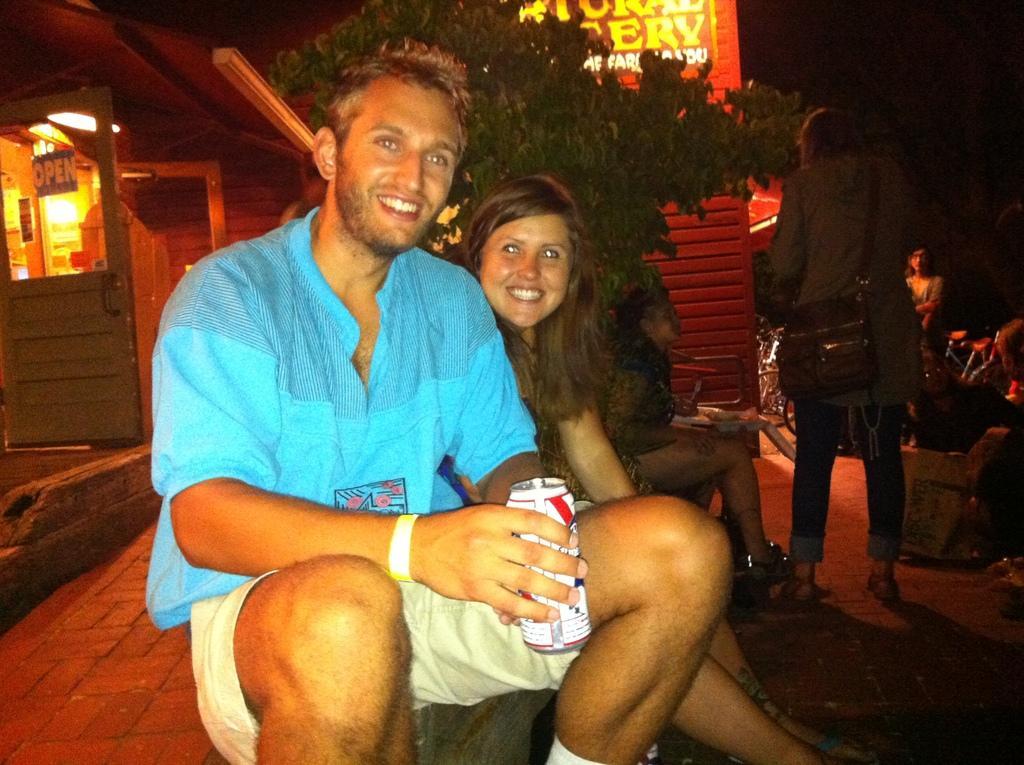Can you describe this image briefly? In the image we can see there are people sitting on the footpath and a man is holding juice can in his hand. Behind there is shop and there is a door on which it's written ¨Open¨. Behind there is a tree and there are other people sitting on the chair. 